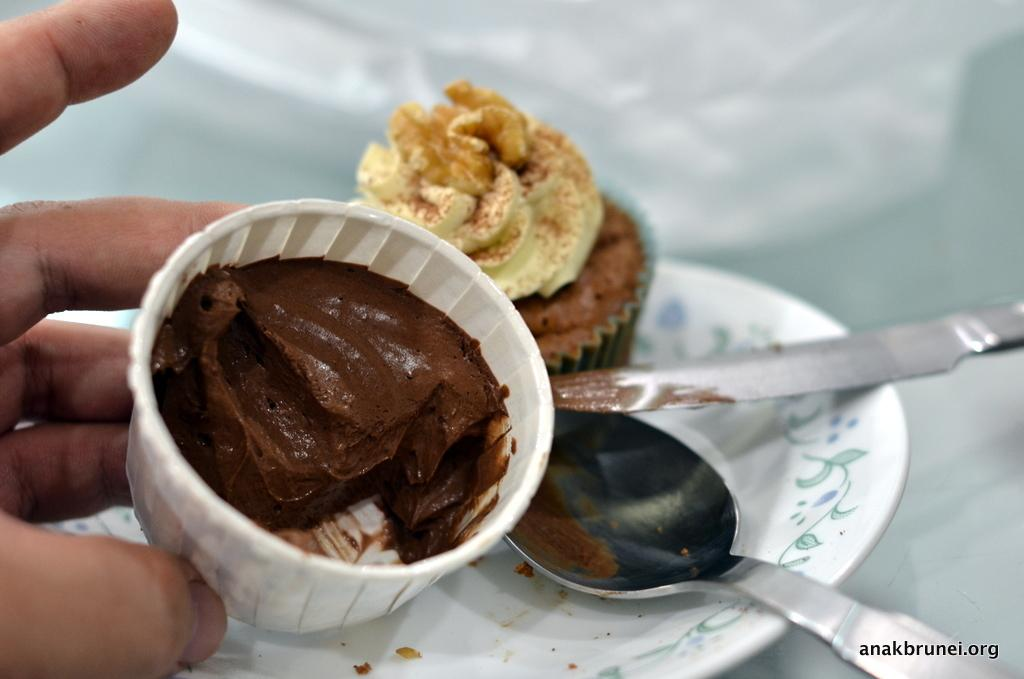What type of food can be seen in the image? There is a muffin in the image. What utensils are present in the image? There is a knife and a spoon in the image. Where are the muffin, knife, and spoon located? They are on a plate in the image. Whose hand is visible in the image? A human hand is visible in the image. What type of fish is being prepared by the maid in the image? There is no fish or maid present in the image. 